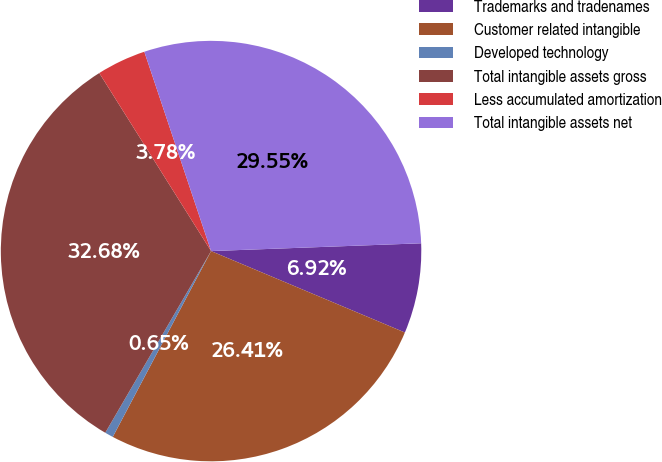Convert chart to OTSL. <chart><loc_0><loc_0><loc_500><loc_500><pie_chart><fcel>Trademarks and tradenames<fcel>Customer related intangible<fcel>Developed technology<fcel>Total intangible assets gross<fcel>Less accumulated amortization<fcel>Total intangible assets net<nl><fcel>6.92%<fcel>26.41%<fcel>0.65%<fcel>32.68%<fcel>3.78%<fcel>29.55%<nl></chart> 